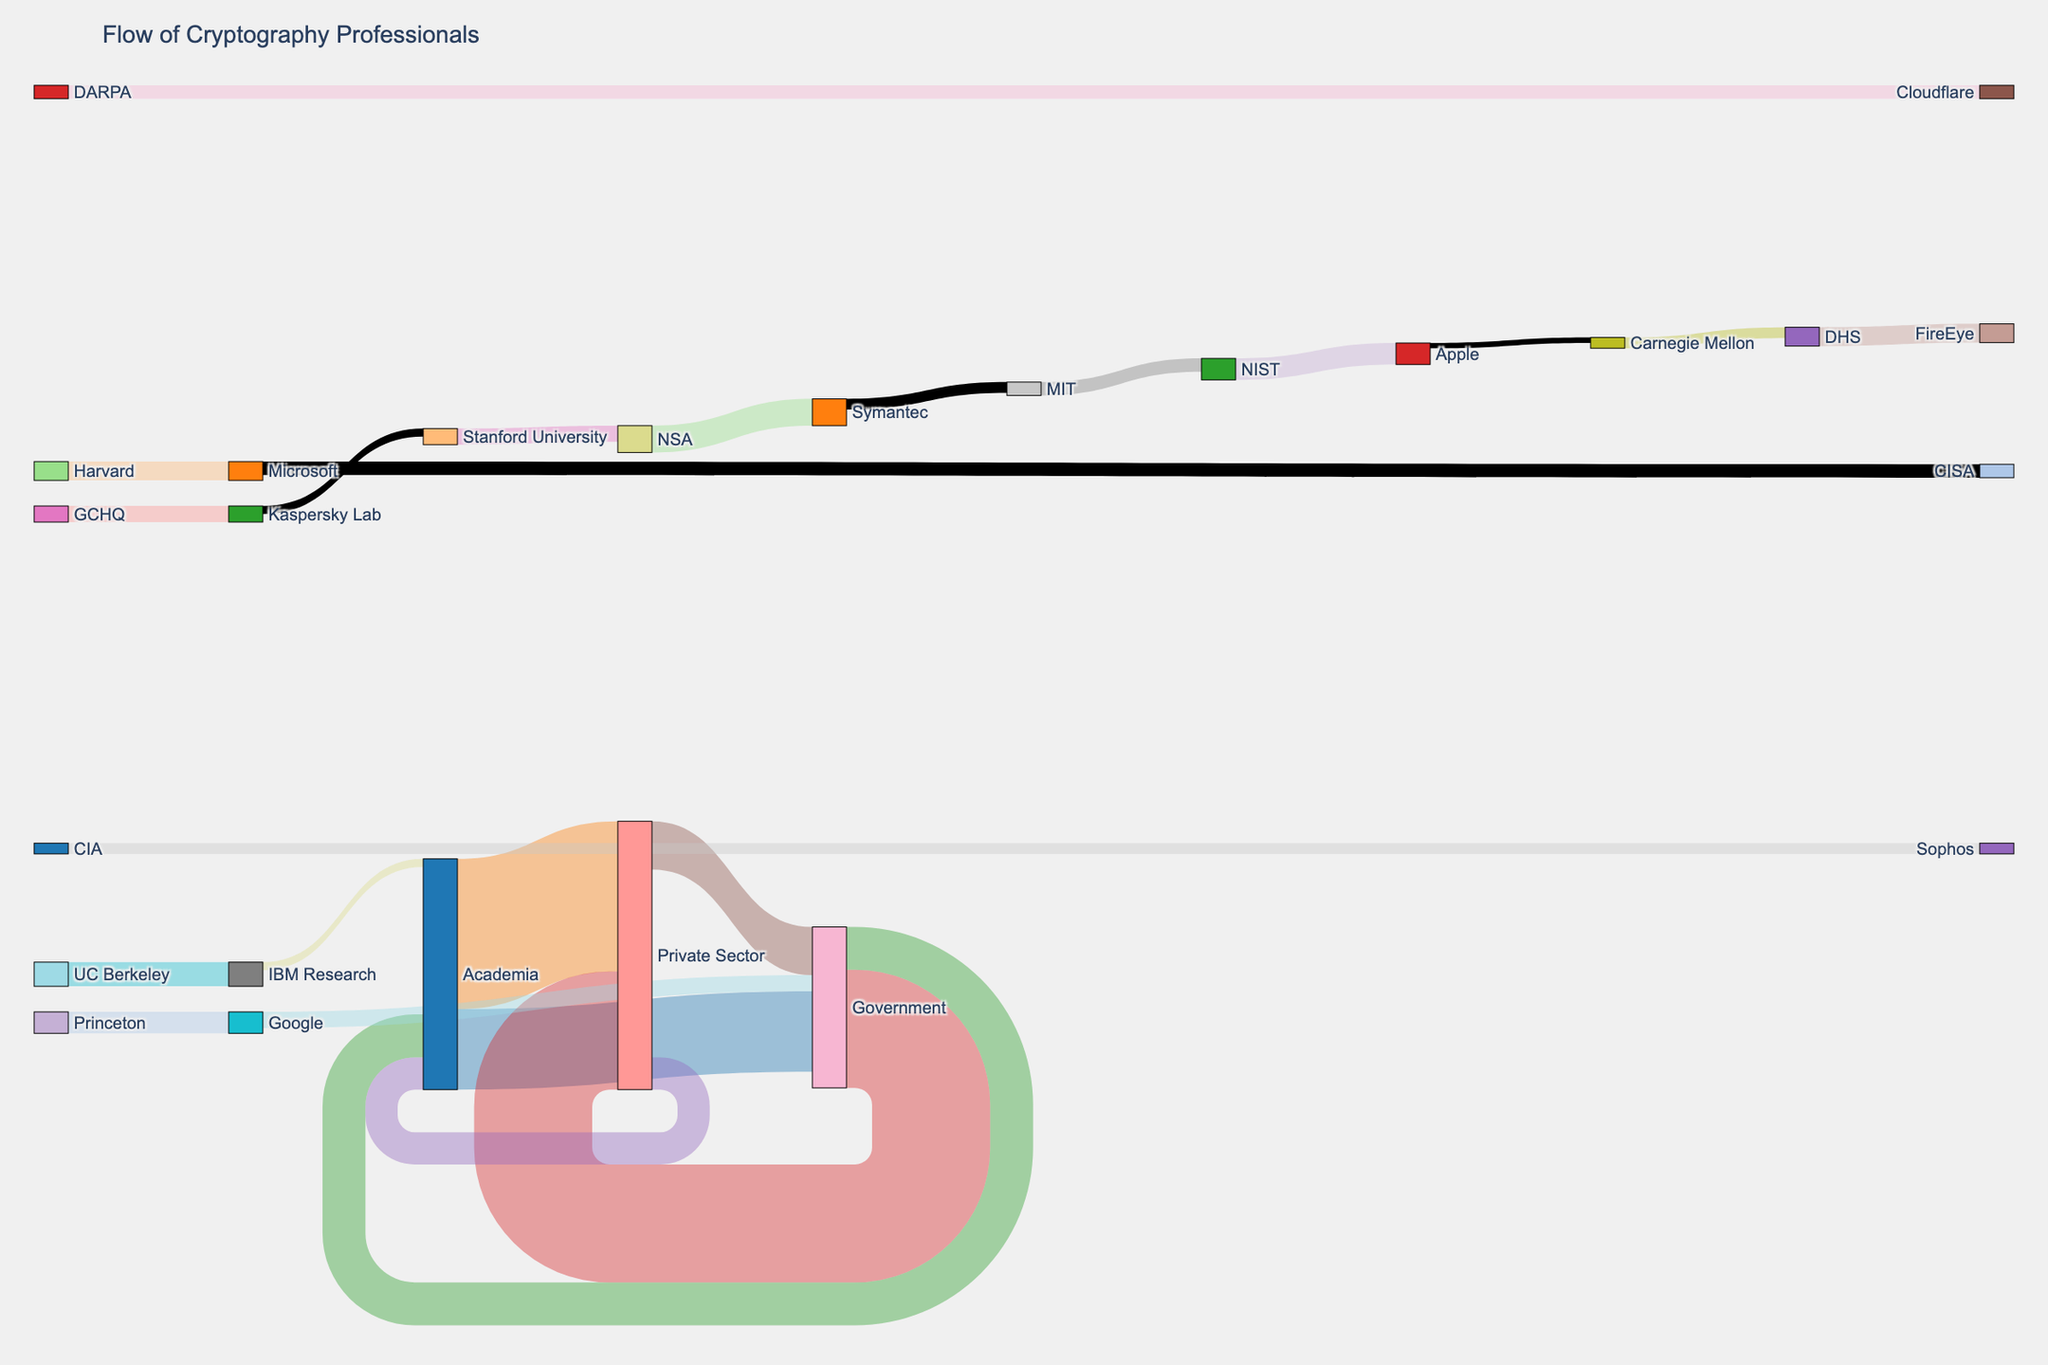Which sector received the most cybersecurity professionals from Academia? By looking at the width of the flows from Academia, we see that the flow to the Private Sector is the widest. Therefore, the most cybersecurity professionals from Academia moved to the Private Sector.
Answer: Private Sector How many professionals moved from Government to Academia? Find the flow labeled Government to Academia. The value shown for this flow is 80.
Answer: 80 What is the total number of professionals who moved from the Private Sector to either Academia or Government? Sum up the values of flows from Private Sector to Academia (60) and Private Sector to Government (90). 60 + 90 = 150.
Answer: 150 Which university sent the most professionals to the private sector? Locate the flows from universities to private companies. UC Berkeley to IBM Research has the highest value at 45.
Answer: UC Berkeley How many professionals moved between Government and the Private Sector? Add the flows Government to Private Sector (220) and Private Sector to Government (90). 220 + 90 = 310.
Answer: 310 Which government agency received the most professionals from universities? Check the flows from universities to government agencies and find the highest value. The flow to NSA from Stanford University is the highest at 30.
Answer: NSA Compare the number of professionals moving from Academia to Private Sector with those moving from Government to Private Sector. Which sector contributed more to the Private Sector? Compare flow values: Academia to Private Sector (280) vs. Government to Private Sector (220). Academia to Private Sector is higher.
Answer: Academia How many professionals moved to Government from either Academia or the Private Sector? Sum flows Academia to Government (150) and Private Sector to Government (90). 150 + 90 = 240.
Answer: 240 Which university supplied the most professionals to IBM Research? Identify the university with the highest flow to IBM Research. It is UC Berkeley with a value of 45.
Answer: UC Berkeley What is the total number of professionals that left the Government sector? Sum up the values of flows leaving Government: Government to Academia (80), Government to Private Sector (220). 80 + 220 = 300.
Answer: 300 